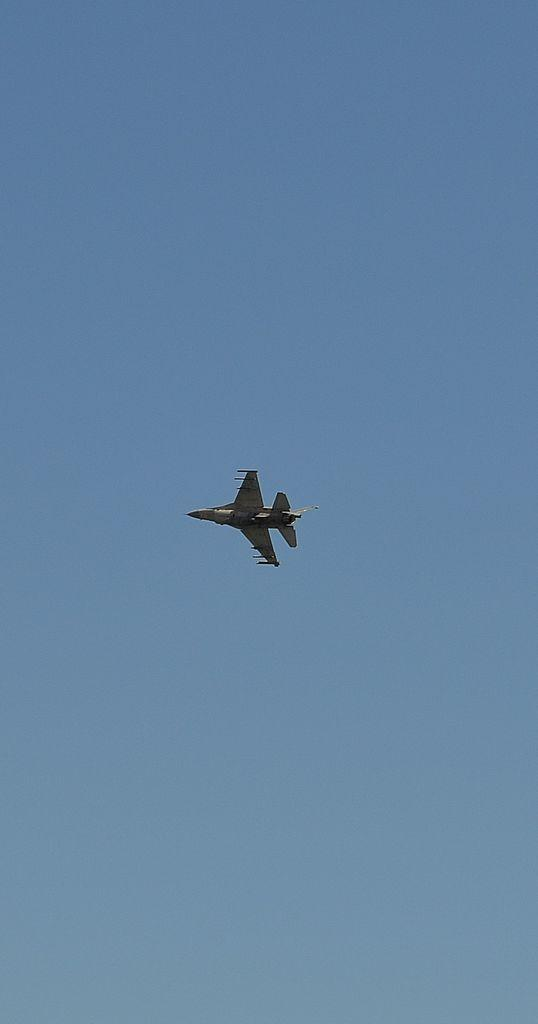What is the main subject of the image? The main subject of the image is an airplane. Where is the airplane located in the image? The airplane is in the air. What can be seen in the background of the image? The sky is visible in the background of the image. What is the color of the sky in the image? The color of the sky is blue. How does the airplane contribute to the wealth of the passengers in the image? The image does not provide any information about the passengers or their wealth, so it is not possible to determine how the airplane might contribute to their wealth. 